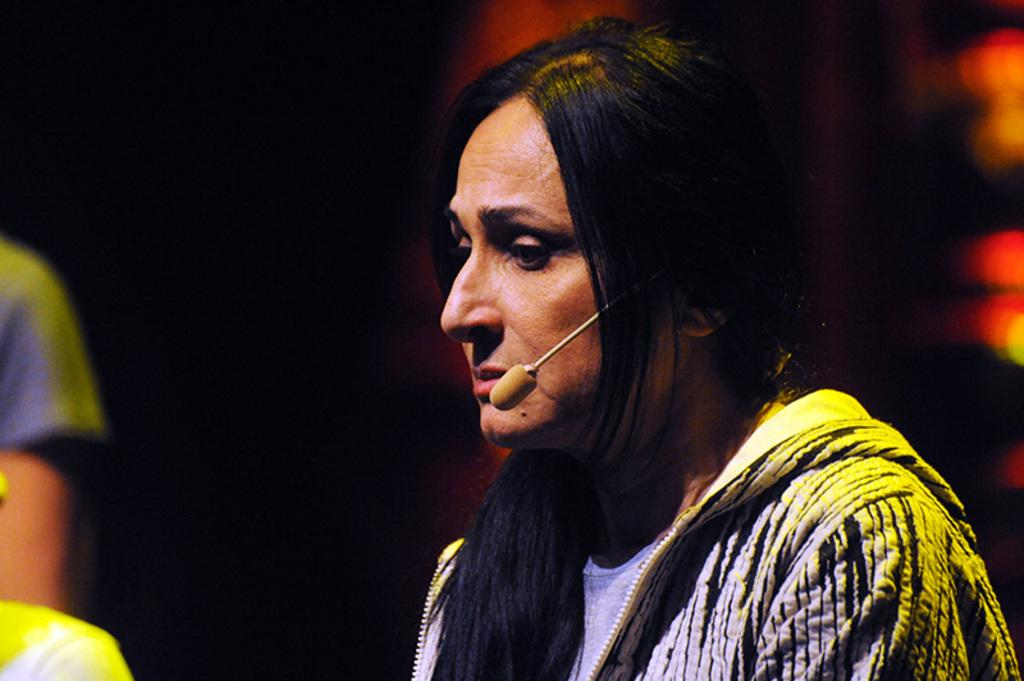Who is the main subject in the image? There is a woman in the image. What is the woman wearing in the image? The woman is wearing a mic in the image. How many persons are on the left side of the image? There are two persons on the left side of the image. What is the color of the background in the image? The background of the image is dark in color. What is the woman's current level of debt in the image? There is no information about the woman's debt in the image. What sense is the woman experiencing in the image? The image does not provide information about the woman's senses. 